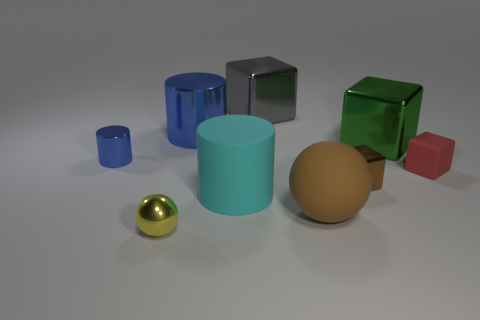Are there any cyan cylinders of the same size as the brown metal cube?
Give a very brief answer. No. There is a tiny metallic object that is behind the tiny matte block; is its shape the same as the big green metal thing?
Keep it short and to the point. No. What is the color of the tiny ball?
Offer a terse response. Yellow. What is the shape of the object that is the same color as the big rubber ball?
Your response must be concise. Cube. Are there any matte balls?
Provide a succinct answer. Yes. What size is the other blue thing that is made of the same material as the big blue thing?
Your answer should be very brief. Small. The big shiny object to the right of the big object in front of the big cylinder that is in front of the small brown metal thing is what shape?
Offer a very short reply. Cube. Are there the same number of small rubber blocks that are in front of the yellow metallic ball and tiny rubber balls?
Give a very brief answer. Yes. There is a shiny object that is the same color as the large matte ball; what size is it?
Your answer should be compact. Small. Is the shape of the small red matte object the same as the tiny yellow object?
Your answer should be compact. No. 